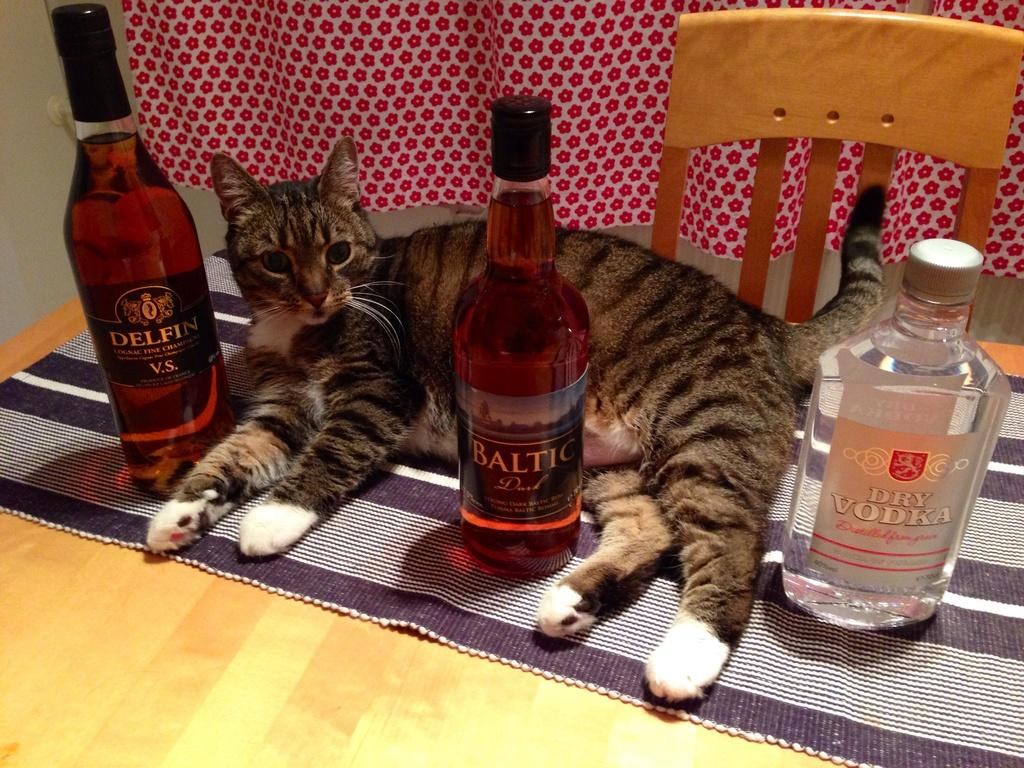What can be seen in the background of the image? There is a wall and a curtain in the background of the image. What type of furniture is present in the image? There is a chair in the image. What animal is visible in the image? A cat is sitting in the image. What objects are on the table? There are bottles on the table. What is placed on the table to protect it from spills or heat? There is a table mat on the table. What type of skirt is the vase wearing in the image? There is no vase or skirt present in the image. What type of spot can be seen on the cat's fur in the image? The image does not show any spots on the cat's fur. 